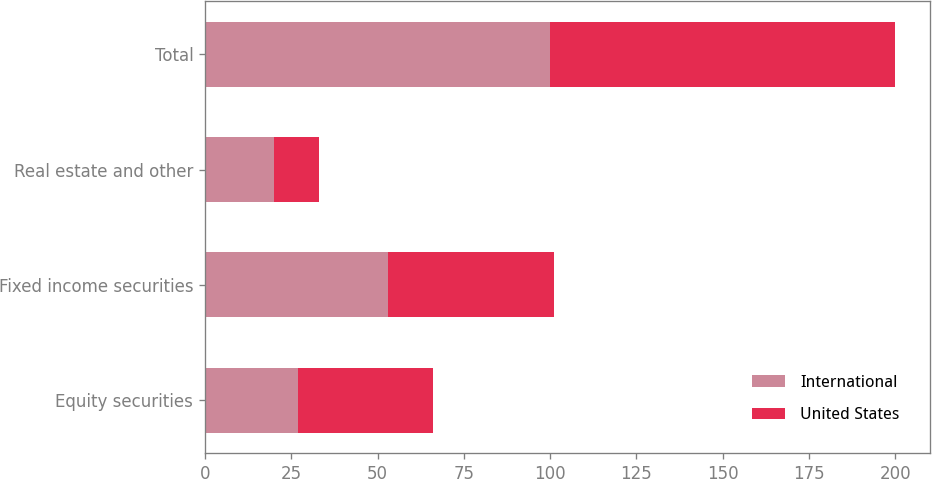Convert chart to OTSL. <chart><loc_0><loc_0><loc_500><loc_500><stacked_bar_chart><ecel><fcel>Equity securities<fcel>Fixed income securities<fcel>Real estate and other<fcel>Total<nl><fcel>International<fcel>27<fcel>53<fcel>20<fcel>100<nl><fcel>United States<fcel>39<fcel>48<fcel>13<fcel>100<nl></chart> 